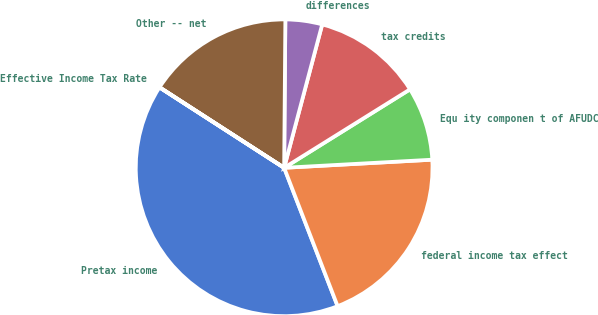Convert chart to OTSL. <chart><loc_0><loc_0><loc_500><loc_500><pie_chart><fcel>Pretax income<fcel>federal income tax effect<fcel>Equ ity componen t of AFUDC<fcel>tax credits<fcel>differences<fcel>Other -- net<fcel>Effective Income Tax Rate<nl><fcel>39.99%<fcel>20.0%<fcel>8.0%<fcel>12.0%<fcel>4.0%<fcel>16.0%<fcel>0.01%<nl></chart> 